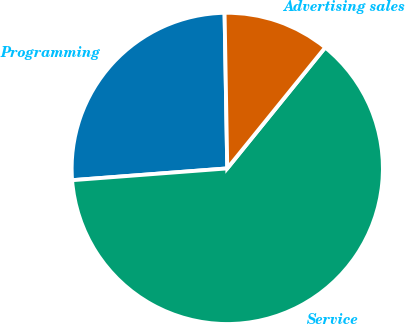Convert chart. <chart><loc_0><loc_0><loc_500><loc_500><pie_chart><fcel>Programming<fcel>Service<fcel>Advertising sales<nl><fcel>25.93%<fcel>62.96%<fcel>11.11%<nl></chart> 